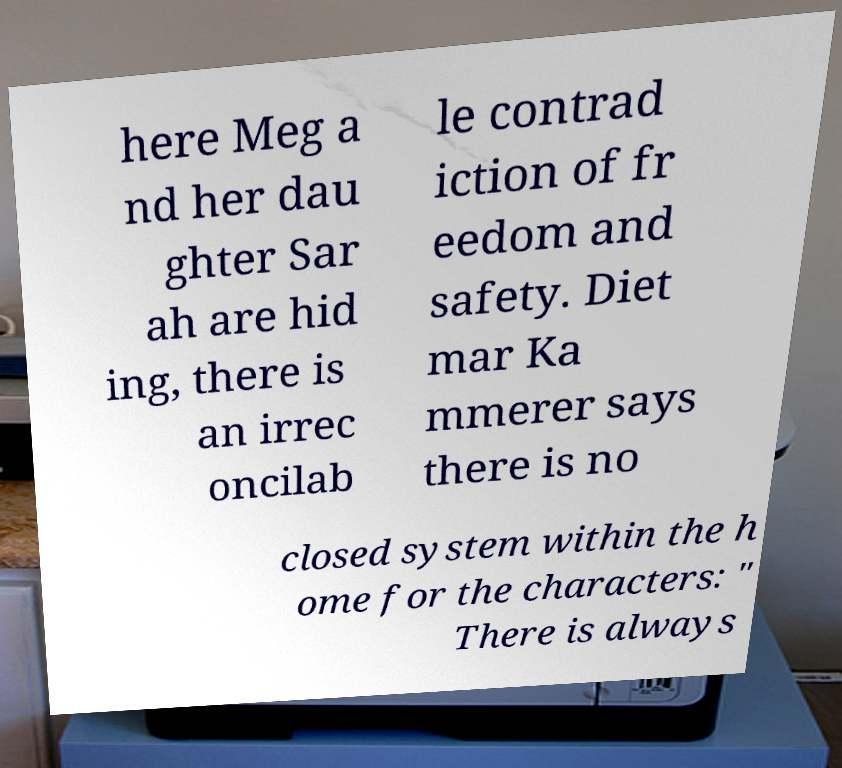Could you extract and type out the text from this image? here Meg a nd her dau ghter Sar ah are hid ing, there is an irrec oncilab le contrad iction of fr eedom and safety. Diet mar Ka mmerer says there is no closed system within the h ome for the characters: " There is always 